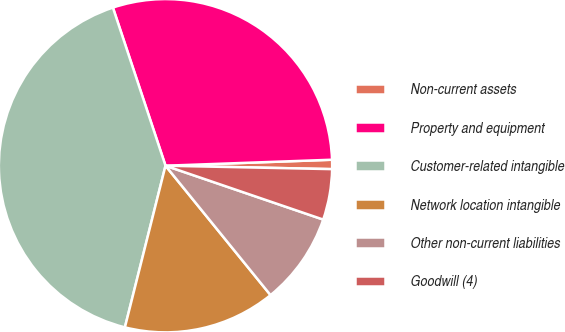Convert chart to OTSL. <chart><loc_0><loc_0><loc_500><loc_500><pie_chart><fcel>Non-current assets<fcel>Property and equipment<fcel>Customer-related intangible<fcel>Network location intangible<fcel>Other non-current liabilities<fcel>Goodwill (4)<nl><fcel>0.9%<fcel>29.54%<fcel>40.97%<fcel>14.77%<fcel>8.91%<fcel>4.91%<nl></chart> 